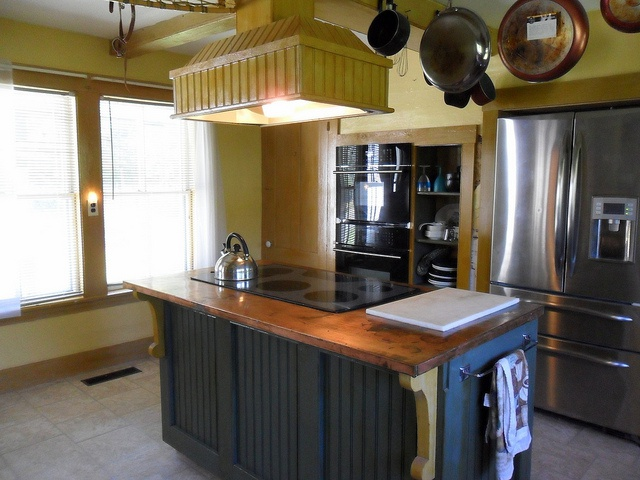Describe the objects in this image and their specific colors. I can see refrigerator in gray, black, darkgray, and lightgray tones, oven in gray, black, white, and darkgray tones, microwave in gray, white, darkgray, and lightblue tones, wine glass in gray, black, navy, and blue tones, and wine glass in gray, black, blue, darkblue, and teal tones in this image. 